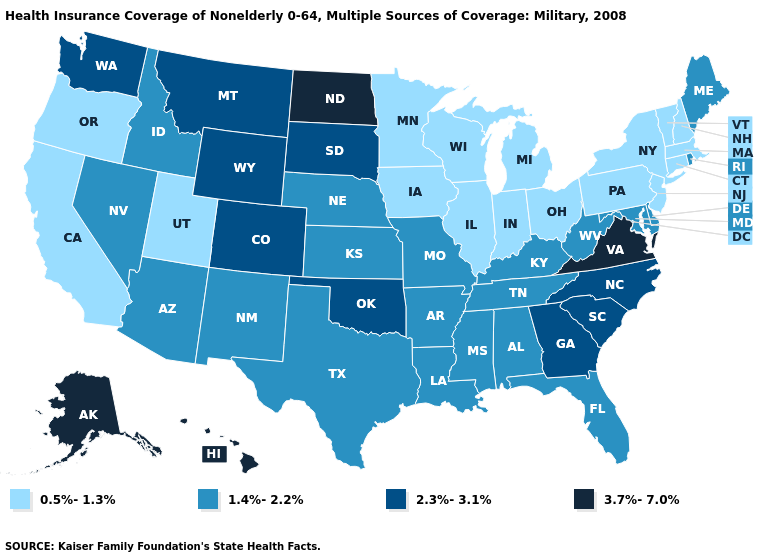Does Alaska have the highest value in the USA?
Quick response, please. Yes. Name the states that have a value in the range 1.4%-2.2%?
Answer briefly. Alabama, Arizona, Arkansas, Delaware, Florida, Idaho, Kansas, Kentucky, Louisiana, Maine, Maryland, Mississippi, Missouri, Nebraska, Nevada, New Mexico, Rhode Island, Tennessee, Texas, West Virginia. What is the value of New Hampshire?
Keep it brief. 0.5%-1.3%. Among the states that border Missouri , does Nebraska have the lowest value?
Short answer required. No. What is the lowest value in the USA?
Concise answer only. 0.5%-1.3%. What is the highest value in the USA?
Short answer required. 3.7%-7.0%. Does Illinois have the highest value in the MidWest?
Answer briefly. No. Does Maine have the highest value in the Northeast?
Quick response, please. Yes. How many symbols are there in the legend?
Concise answer only. 4. How many symbols are there in the legend?
Short answer required. 4. What is the value of West Virginia?
Give a very brief answer. 1.4%-2.2%. Which states have the highest value in the USA?
Answer briefly. Alaska, Hawaii, North Dakota, Virginia. How many symbols are there in the legend?
Keep it brief. 4. What is the lowest value in states that border Rhode Island?
Write a very short answer. 0.5%-1.3%. Among the states that border California , which have the lowest value?
Concise answer only. Oregon. 